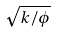<formula> <loc_0><loc_0><loc_500><loc_500>\sqrt { k / \phi }</formula> 